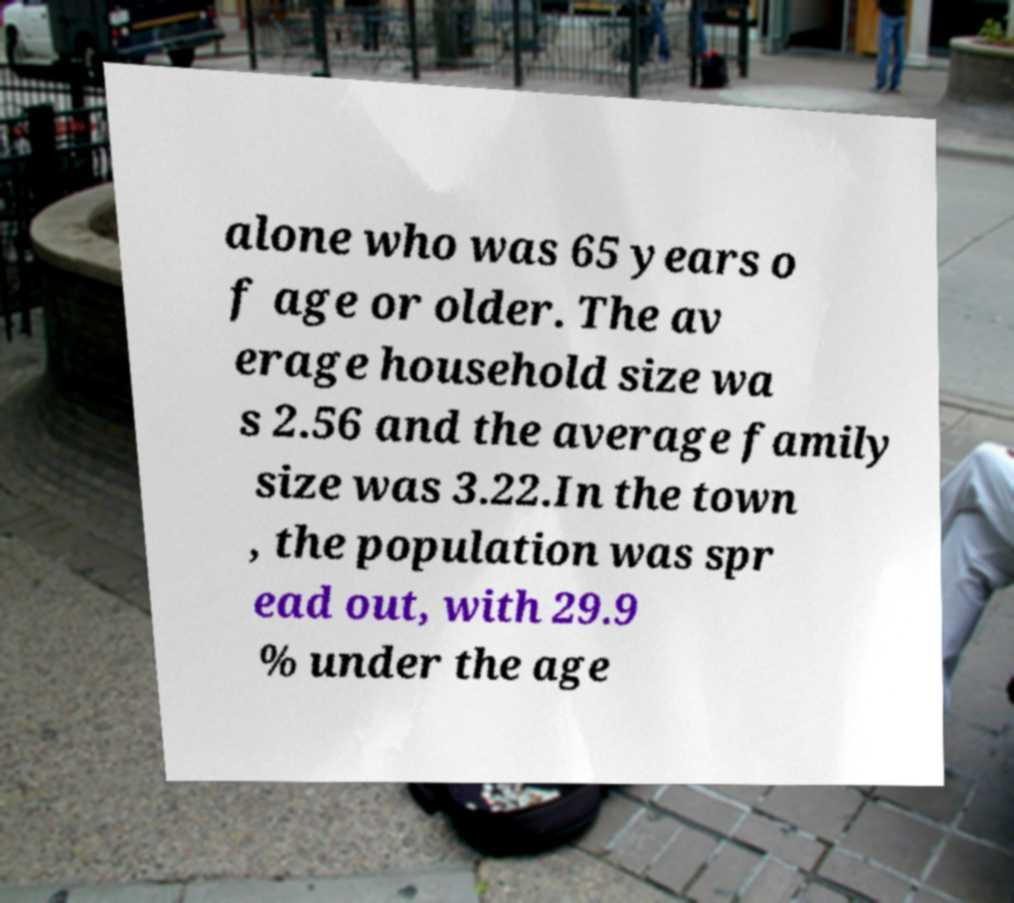I need the written content from this picture converted into text. Can you do that? alone who was 65 years o f age or older. The av erage household size wa s 2.56 and the average family size was 3.22.In the town , the population was spr ead out, with 29.9 % under the age 